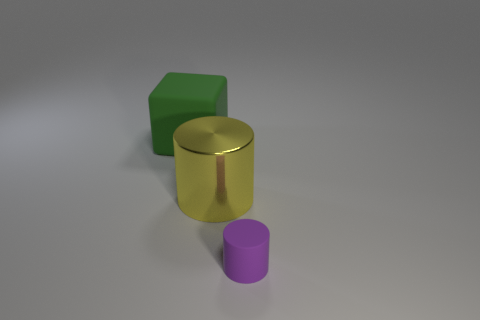The yellow metallic cylinder is what size?
Give a very brief answer. Large. There is a matte cylinder; is its size the same as the rubber object to the left of the purple rubber object?
Provide a succinct answer. No. There is a large thing that is in front of the matte object that is behind the small purple object; what color is it?
Make the answer very short. Yellow. Is the number of big green blocks that are right of the tiny purple rubber cylinder the same as the number of large green matte objects that are to the right of the green cube?
Keep it short and to the point. Yes. Do the cylinder that is left of the small object and the small thing have the same material?
Provide a succinct answer. No. What color is the thing that is in front of the green object and behind the tiny rubber object?
Give a very brief answer. Yellow. There is a rubber object to the right of the large matte block; what number of matte cubes are right of it?
Offer a very short reply. 0. There is a small purple object that is the same shape as the large yellow thing; what is its material?
Offer a very short reply. Rubber. What color is the large block?
Provide a short and direct response. Green. What number of things are either gray cylinders or big yellow shiny cylinders?
Your answer should be very brief. 1. 